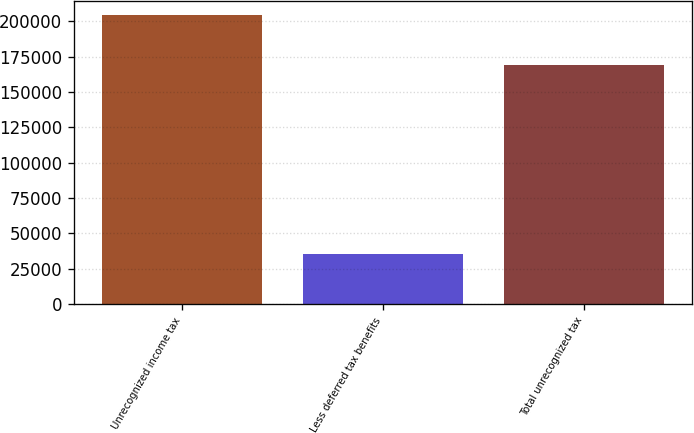Convert chart. <chart><loc_0><loc_0><loc_500><loc_500><bar_chart><fcel>Unrecognized income tax<fcel>Less deferred tax benefits<fcel>Total unrecognized tax<nl><fcel>204515<fcel>35474<fcel>169041<nl></chart> 